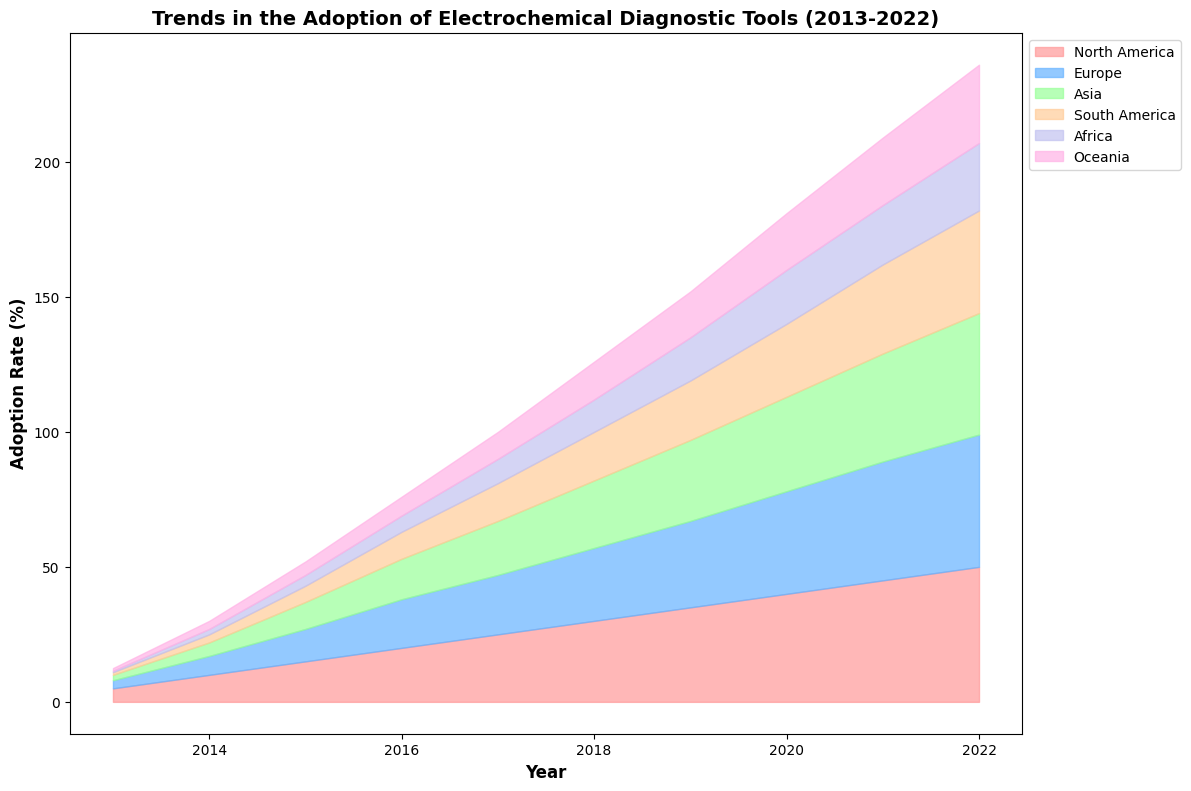What is the overall trend in the adoption of electrochemical diagnostic tools in North America from 2013 to 2022? The adoption rate in North America increases steadily from 5% in 2013 to 50% in 2022. This can be seen by the rising area of the section representing North America.
Answer: Steady increase Compare the adoption rates of Europe and Asia in 2022. Which one has a higher rate? The adoption rate for Europe in 2022 is 49%, while for Asia it is 45%. By comparing the top ends of their corresponding areas in the plot, it's clear Europe has a higher rate.
Answer: Europe Which region started with the lowest adoption rate in 2013 and what was the rate? In 2013, Africa started with the lowest adoption rate at 0.5%. This can be observed as the smallest area at the bottom of the chart for that year.
Answer: Africa, 0.5% How much did the adoption rate for South America increase between 2013 and 2022? The adoption rate for South America increased from 1% in 2013 to 38% in 2022. The increase is calculated as 38% - 1% = 37%.
Answer: 37% Which region saw the largest increase in the adoption rate between 2013 and 2022? North America saw the largest increase, from 5% in 2013 to 50% in 2022, an increase of 45%. This larger increase is reflected by the greater growth in the area representing North America over time.
Answer: North America In what year did Europe surpass Asia in the adoption rate, and by how much? Europe surpassed Asia in adoption rate in 2014, with Europe at 7% and Asia at 5%. The difference is 2%. This can be observed by the area overlap where Europa's area overtakes Asia.
Answer: 2014, 2% By how much did the adoption rate for Africa increase between 2016 and 2019? The adoption rate for Africa increased from 6% in 2016 to 16% in 2019. The increase is 16% - 6% = 10%. This can be found by measuring the difference in height of Africa's area in these years.
Answer: 10% What is the cumulative adoption rate of all regions in 2020? The cumulative adoption rate in 2020 is the sum of the adoption rates of all regions: North America (40%), Europe (38%), Asia (35%), South America (27%), Africa (20%), and Oceania (21%). The sum is 40% + 38% + 35% + 27% + 20% + 21% = 181%.
Answer: 181% Compare the adoption rates of Oceania and Africa in 2018. Which one has a higher rate and by how much? In 2018, Oceania had an adoption rate of 14%, while Africa had 12%. Oceania's rate is higher by 2%. This is observed by the comparing area heights of these regions in 2018.
Answer: Oceania, 2% 